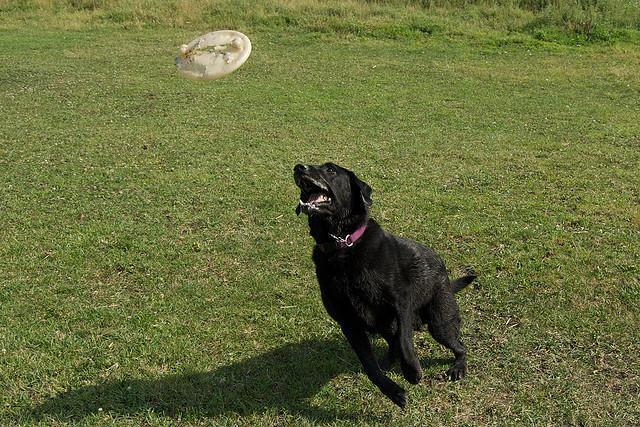How many animals are pictured?
Give a very brief answer. 1. How many dogs do you see?
Give a very brief answer. 1. 